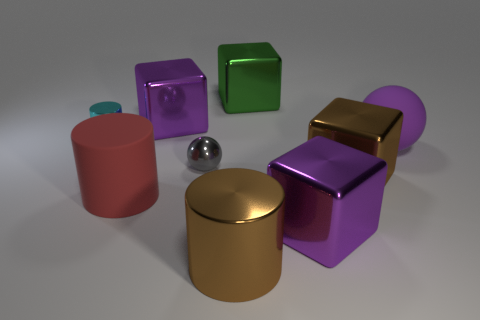How many other objects are the same material as the green block?
Keep it short and to the point. 6. How many things are either shiny balls or large blocks that are to the right of the big brown metal cylinder?
Offer a very short reply. 4. Is the number of things less than the number of purple things?
Keep it short and to the point. No. There is a sphere that is to the left of the matte thing right of the large purple metallic thing that is behind the cyan object; what color is it?
Offer a terse response. Gray. Does the big brown cylinder have the same material as the tiny ball?
Give a very brief answer. Yes. There is a cyan cylinder; what number of purple metallic things are in front of it?
Ensure brevity in your answer.  1. What size is the purple matte thing that is the same shape as the small gray shiny thing?
Your answer should be compact. Large. What number of green objects are either large metal cubes or big matte objects?
Your answer should be compact. 1. How many matte spheres are to the right of the tiny metal object that is in front of the purple matte ball?
Your answer should be very brief. 1. What number of other things are there of the same shape as the purple rubber object?
Your answer should be very brief. 1. 